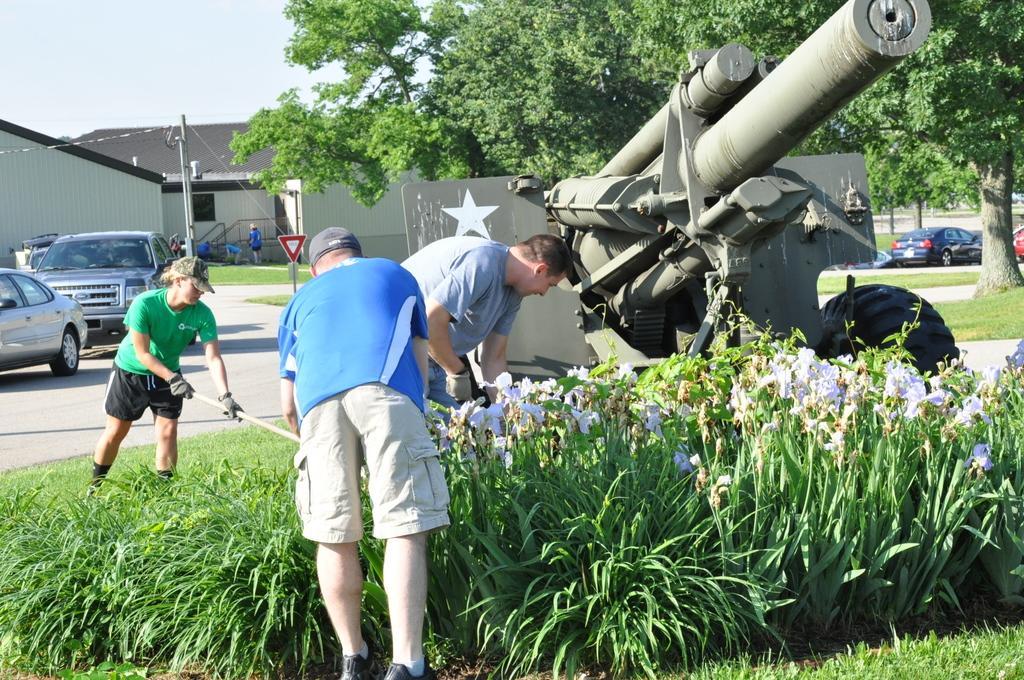Could you give a brief overview of what you see in this image? Here we can see three persons and he is holding a stick with his hands. This is grass. There are plants and flowers. There are vehicles on the road. Here we can see a pole, sheds, board, trees, and few persons. In the background there is sky. 